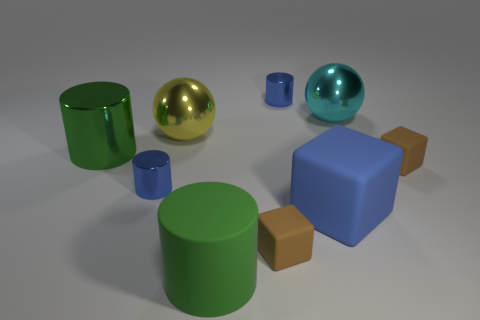How many objects are brown things or big cylinders that are behind the green rubber thing?
Offer a very short reply. 3. Is the number of big spheres on the left side of the large cyan thing less than the number of large cyan spheres in front of the big blue matte thing?
Provide a succinct answer. No. What number of other objects are there of the same material as the big blue object?
Ensure brevity in your answer.  3. Is the color of the large sphere to the right of the yellow thing the same as the large matte cylinder?
Provide a succinct answer. No. Is there a thing behind the large metal cylinder that is behind the big matte block?
Offer a very short reply. Yes. What is the material of the object that is both in front of the cyan object and to the right of the big blue rubber object?
Provide a succinct answer. Rubber. There is a large cyan thing that is the same material as the large yellow sphere; what shape is it?
Keep it short and to the point. Sphere. Are there any other things that have the same shape as the big cyan object?
Make the answer very short. Yes. Are the big thing to the left of the big yellow sphere and the large cyan sphere made of the same material?
Offer a terse response. Yes. There is a brown block that is behind the blue rubber block; what is it made of?
Offer a terse response. Rubber. 